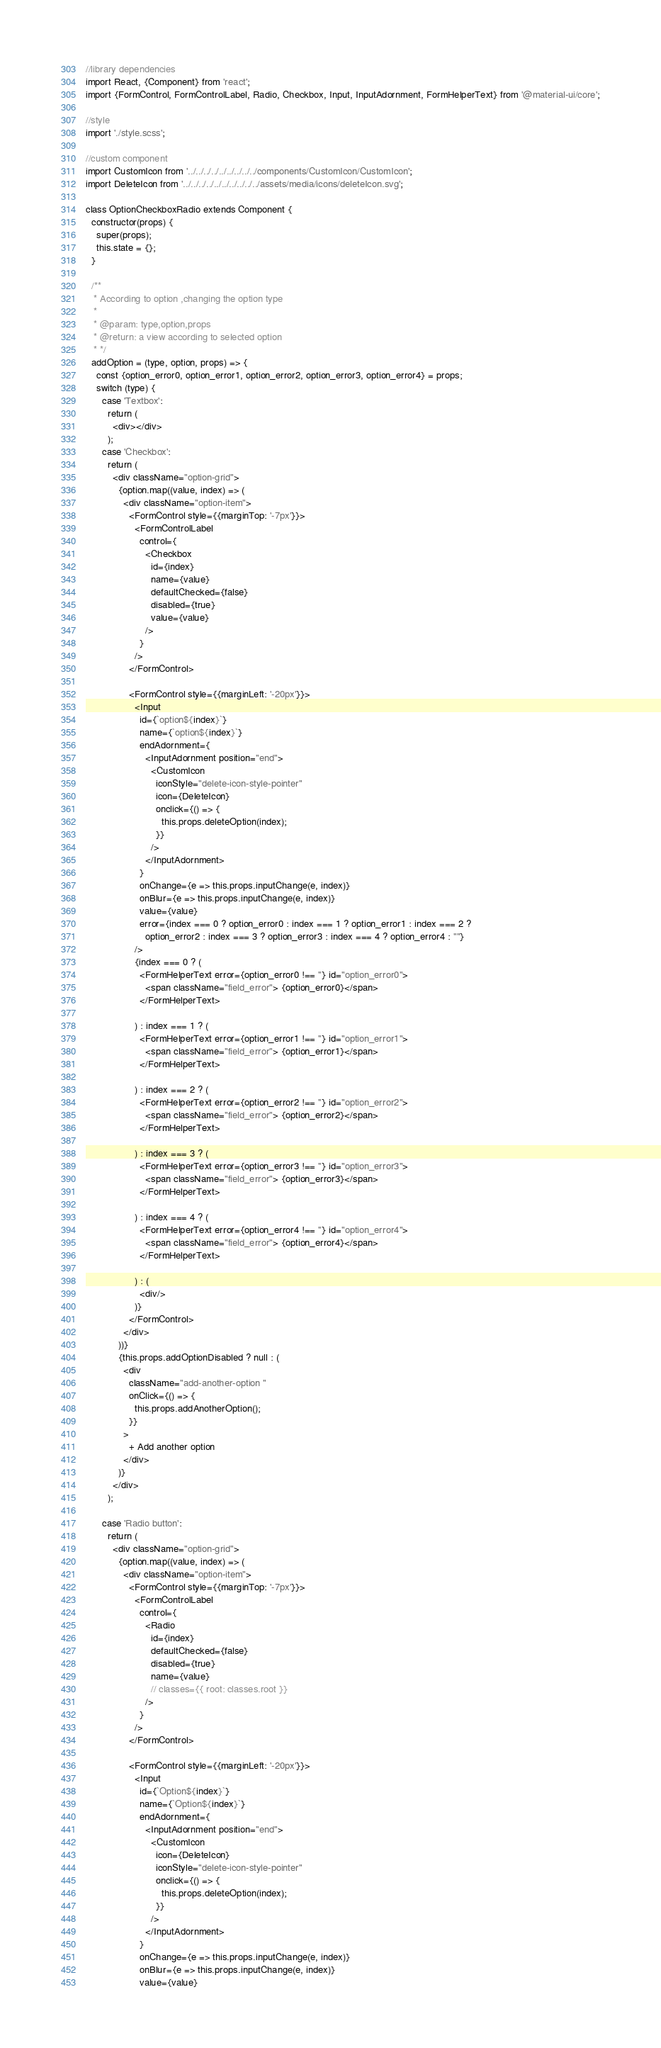<code> <loc_0><loc_0><loc_500><loc_500><_JavaScript_>//library dependencies
import React, {Component} from 'react';
import {FormControl, FormControlLabel, Radio, Checkbox, Input, InputAdornment, FormHelperText} from '@material-ui/core';

//style
import './style.scss';

//custom component
import CustomIcon from '../../../../../../../../../components/CustomIcon/CustomIcon';
import DeleteIcon from '../../../../../../../../../../assets/media/icons/deleteIcon.svg';

class OptionCheckboxRadio extends Component {
  constructor(props) {
    super(props);
    this.state = {};
  }

  /**
   * According to option ,changing the option type
   *
   * @param: type,option,props
   * @return: a view according to selected option
   * */
  addOption = (type, option, props) => {
    const {option_error0, option_error1, option_error2, option_error3, option_error4} = props;
    switch (type) {
      case 'Textbox':
        return (
          <div></div>
        );
      case 'Checkbox':
        return (
          <div className="option-grid">
            {option.map((value, index) => (
              <div className="option-item">
                <FormControl style={{marginTop: '-7px'}}>
                  <FormControlLabel
                    control={
                      <Checkbox
                        id={index}
                        name={value}
                        defaultChecked={false}
                        disabled={true}
                        value={value}
                      />
                    }
                  />
                </FormControl>

                <FormControl style={{marginLeft: '-20px'}}>
                  <Input
                    id={`option${index}`}
                    name={`option${index}`}
                    endAdornment={
                      <InputAdornment position="end">
                        <CustomIcon
                          iconStyle="delete-icon-style-pointer"
                          icon={DeleteIcon}
                          onclick={() => {
                            this.props.deleteOption(index);
                          }}
                        />
                      </InputAdornment>
                    }
                    onChange={e => this.props.inputChange(e, index)}
                    onBlur={e => this.props.inputChange(e, index)}
                    value={value}
                    error={index === 0 ? option_error0 : index === 1 ? option_error1 : index === 2 ?
                      option_error2 : index === 3 ? option_error3 : index === 4 ? option_error4 : ""}
                  />
                  {index === 0 ? (
                    <FormHelperText error={option_error0 !== ''} id="option_error0">
                      <span className="field_error"> {option_error0}</span>
                    </FormHelperText>

                  ) : index === 1 ? (
                    <FormHelperText error={option_error1 !== ''} id="option_error1">
                      <span className="field_error"> {option_error1}</span>
                    </FormHelperText>

                  ) : index === 2 ? (
                    <FormHelperText error={option_error2 !== ''} id="option_error2">
                      <span className="field_error"> {option_error2}</span>
                    </FormHelperText>

                  ) : index === 3 ? (
                    <FormHelperText error={option_error3 !== ''} id="option_error3">
                      <span className="field_error"> {option_error3}</span>
                    </FormHelperText>

                  ) : index === 4 ? (
                    <FormHelperText error={option_error4 !== ''} id="option_error4">
                      <span className="field_error"> {option_error4}</span>
                    </FormHelperText>

                  ) : (
                    <div/>
                  )}
                </FormControl>
              </div>
            ))}
            {this.props.addOptionDisabled ? null : (
              <div
                className="add-another-option "
                onClick={() => {
                  this.props.addAnotherOption();
                }}
              >
                + Add another option
              </div>
            )}
          </div>
        );

      case 'Radio button':
        return (
          <div className="option-grid">
            {option.map((value, index) => (
              <div className="option-item">
                <FormControl style={{marginTop: '-7px'}}>
                  <FormControlLabel
                    control={
                      <Radio
                        id={index}
                        defaultChecked={false}
                        disabled={true}
                        name={value}
                        // classes={{ root: classes.root }}
                      />
                    }
                  />
                </FormControl>

                <FormControl style={{marginLeft: '-20px'}}>
                  <Input
                    id={`Option${index}`}
                    name={`Option${index}`}
                    endAdornment={
                      <InputAdornment position="end">
                        <CustomIcon
                          icon={DeleteIcon}
                          iconStyle="delete-icon-style-pointer"
                          onclick={() => {
                            this.props.deleteOption(index);
                          }}
                        />
                      </InputAdornment>
                    }
                    onChange={e => this.props.inputChange(e, index)}
                    onBlur={e => this.props.inputChange(e, index)}
                    value={value}</code> 